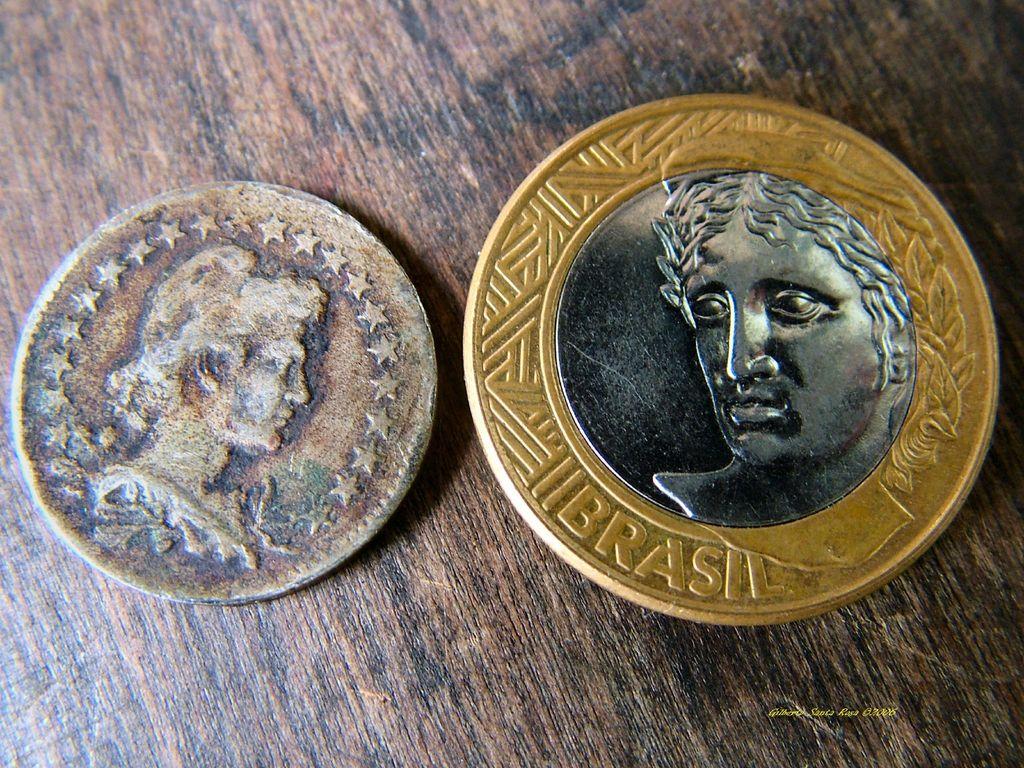Where is the right coin from?
Ensure brevity in your answer.  Brasil. 